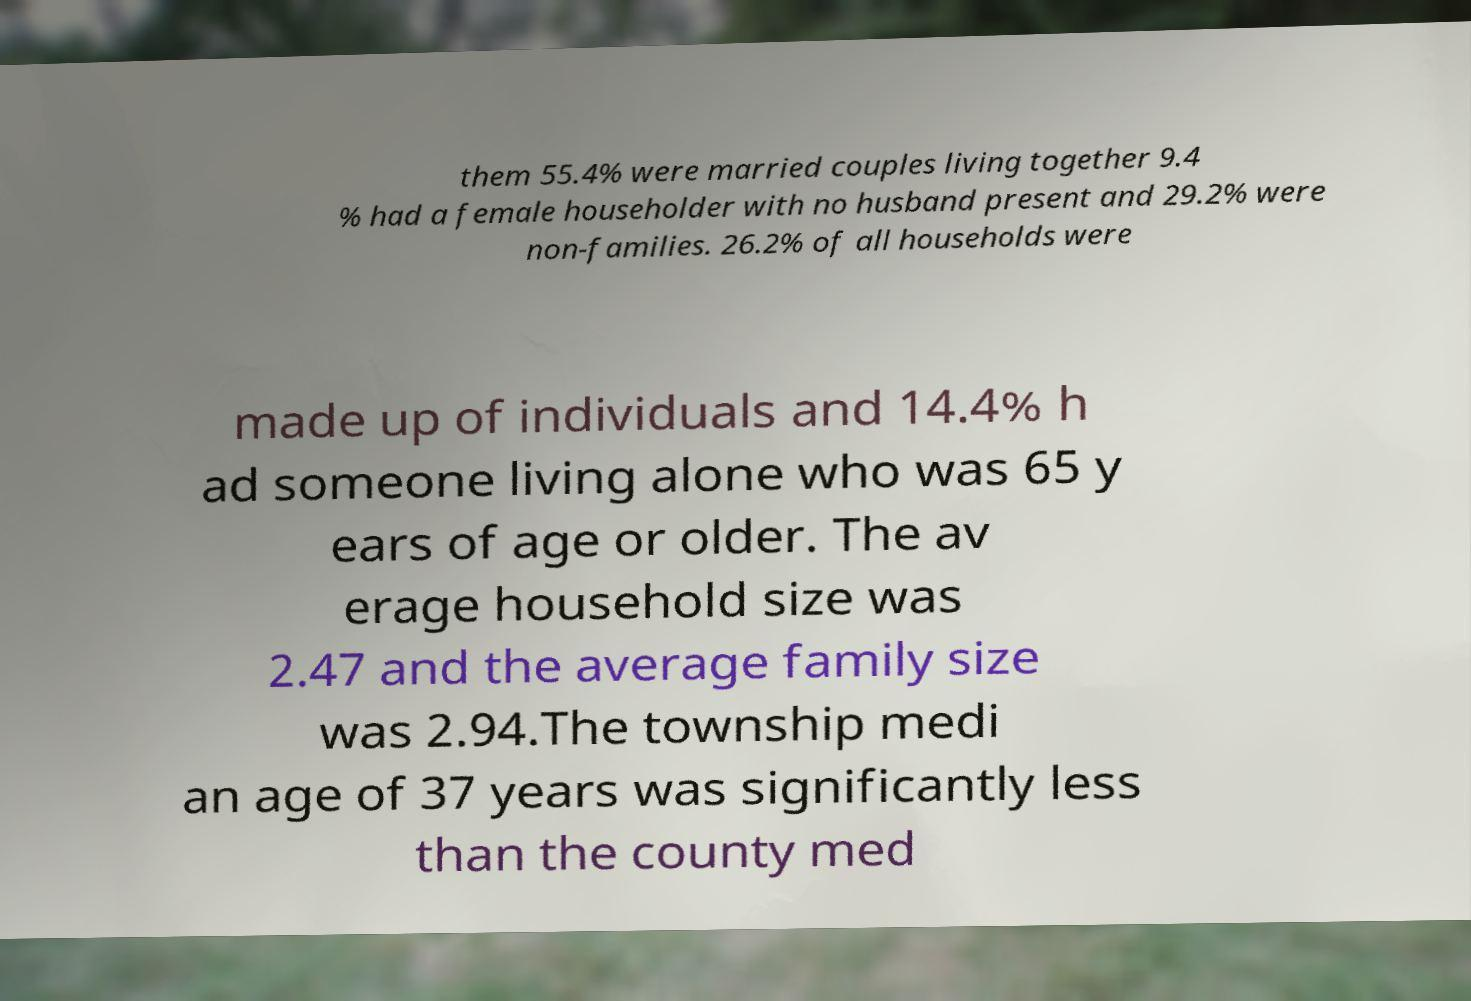Can you accurately transcribe the text from the provided image for me? them 55.4% were married couples living together 9.4 % had a female householder with no husband present and 29.2% were non-families. 26.2% of all households were made up of individuals and 14.4% h ad someone living alone who was 65 y ears of age or older. The av erage household size was 2.47 and the average family size was 2.94.The township medi an age of 37 years was significantly less than the county med 